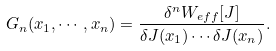Convert formula to latex. <formula><loc_0><loc_0><loc_500><loc_500>G _ { n } ( x _ { 1 } , \cdots , x _ { n } ) = \frac { \delta ^ { n } W _ { e f f } [ J ] } { \delta J ( x _ { 1 } ) \cdots \delta J ( x _ { n } ) } .</formula> 